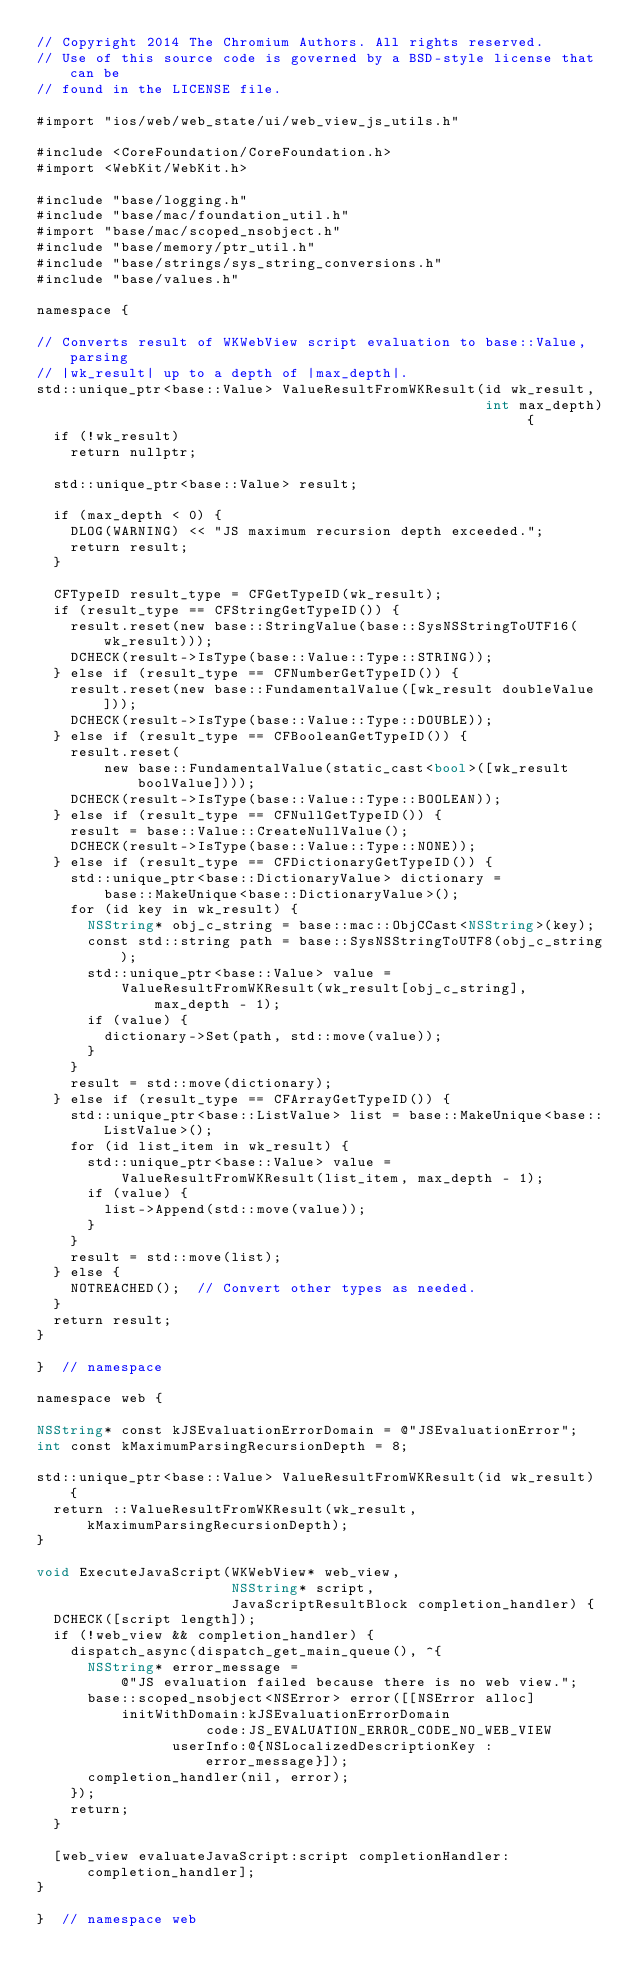Convert code to text. <code><loc_0><loc_0><loc_500><loc_500><_ObjectiveC_>// Copyright 2014 The Chromium Authors. All rights reserved.
// Use of this source code is governed by a BSD-style license that can be
// found in the LICENSE file.

#import "ios/web/web_state/ui/web_view_js_utils.h"

#include <CoreFoundation/CoreFoundation.h>
#import <WebKit/WebKit.h>

#include "base/logging.h"
#include "base/mac/foundation_util.h"
#import "base/mac/scoped_nsobject.h"
#include "base/memory/ptr_util.h"
#include "base/strings/sys_string_conversions.h"
#include "base/values.h"

namespace {

// Converts result of WKWebView script evaluation to base::Value, parsing
// |wk_result| up to a depth of |max_depth|.
std::unique_ptr<base::Value> ValueResultFromWKResult(id wk_result,
                                                     int max_depth) {
  if (!wk_result)
    return nullptr;

  std::unique_ptr<base::Value> result;

  if (max_depth < 0) {
    DLOG(WARNING) << "JS maximum recursion depth exceeded.";
    return result;
  }

  CFTypeID result_type = CFGetTypeID(wk_result);
  if (result_type == CFStringGetTypeID()) {
    result.reset(new base::StringValue(base::SysNSStringToUTF16(wk_result)));
    DCHECK(result->IsType(base::Value::Type::STRING));
  } else if (result_type == CFNumberGetTypeID()) {
    result.reset(new base::FundamentalValue([wk_result doubleValue]));
    DCHECK(result->IsType(base::Value::Type::DOUBLE));
  } else if (result_type == CFBooleanGetTypeID()) {
    result.reset(
        new base::FundamentalValue(static_cast<bool>([wk_result boolValue])));
    DCHECK(result->IsType(base::Value::Type::BOOLEAN));
  } else if (result_type == CFNullGetTypeID()) {
    result = base::Value::CreateNullValue();
    DCHECK(result->IsType(base::Value::Type::NONE));
  } else if (result_type == CFDictionaryGetTypeID()) {
    std::unique_ptr<base::DictionaryValue> dictionary =
        base::MakeUnique<base::DictionaryValue>();
    for (id key in wk_result) {
      NSString* obj_c_string = base::mac::ObjCCast<NSString>(key);
      const std::string path = base::SysNSStringToUTF8(obj_c_string);
      std::unique_ptr<base::Value> value =
          ValueResultFromWKResult(wk_result[obj_c_string], max_depth - 1);
      if (value) {
        dictionary->Set(path, std::move(value));
      }
    }
    result = std::move(dictionary);
  } else if (result_type == CFArrayGetTypeID()) {
    std::unique_ptr<base::ListValue> list = base::MakeUnique<base::ListValue>();
    for (id list_item in wk_result) {
      std::unique_ptr<base::Value> value =
          ValueResultFromWKResult(list_item, max_depth - 1);
      if (value) {
        list->Append(std::move(value));
      }
    }
    result = std::move(list);
  } else {
    NOTREACHED();  // Convert other types as needed.
  }
  return result;
}

}  // namespace

namespace web {

NSString* const kJSEvaluationErrorDomain = @"JSEvaluationError";
int const kMaximumParsingRecursionDepth = 8;

std::unique_ptr<base::Value> ValueResultFromWKResult(id wk_result) {
  return ::ValueResultFromWKResult(wk_result, kMaximumParsingRecursionDepth);
}

void ExecuteJavaScript(WKWebView* web_view,
                       NSString* script,
                       JavaScriptResultBlock completion_handler) {
  DCHECK([script length]);
  if (!web_view && completion_handler) {
    dispatch_async(dispatch_get_main_queue(), ^{
      NSString* error_message =
          @"JS evaluation failed because there is no web view.";
      base::scoped_nsobject<NSError> error([[NSError alloc]
          initWithDomain:kJSEvaluationErrorDomain
                    code:JS_EVALUATION_ERROR_CODE_NO_WEB_VIEW
                userInfo:@{NSLocalizedDescriptionKey : error_message}]);
      completion_handler(nil, error);
    });
    return;
  }

  [web_view evaluateJavaScript:script completionHandler:completion_handler];
}

}  // namespace web
</code> 